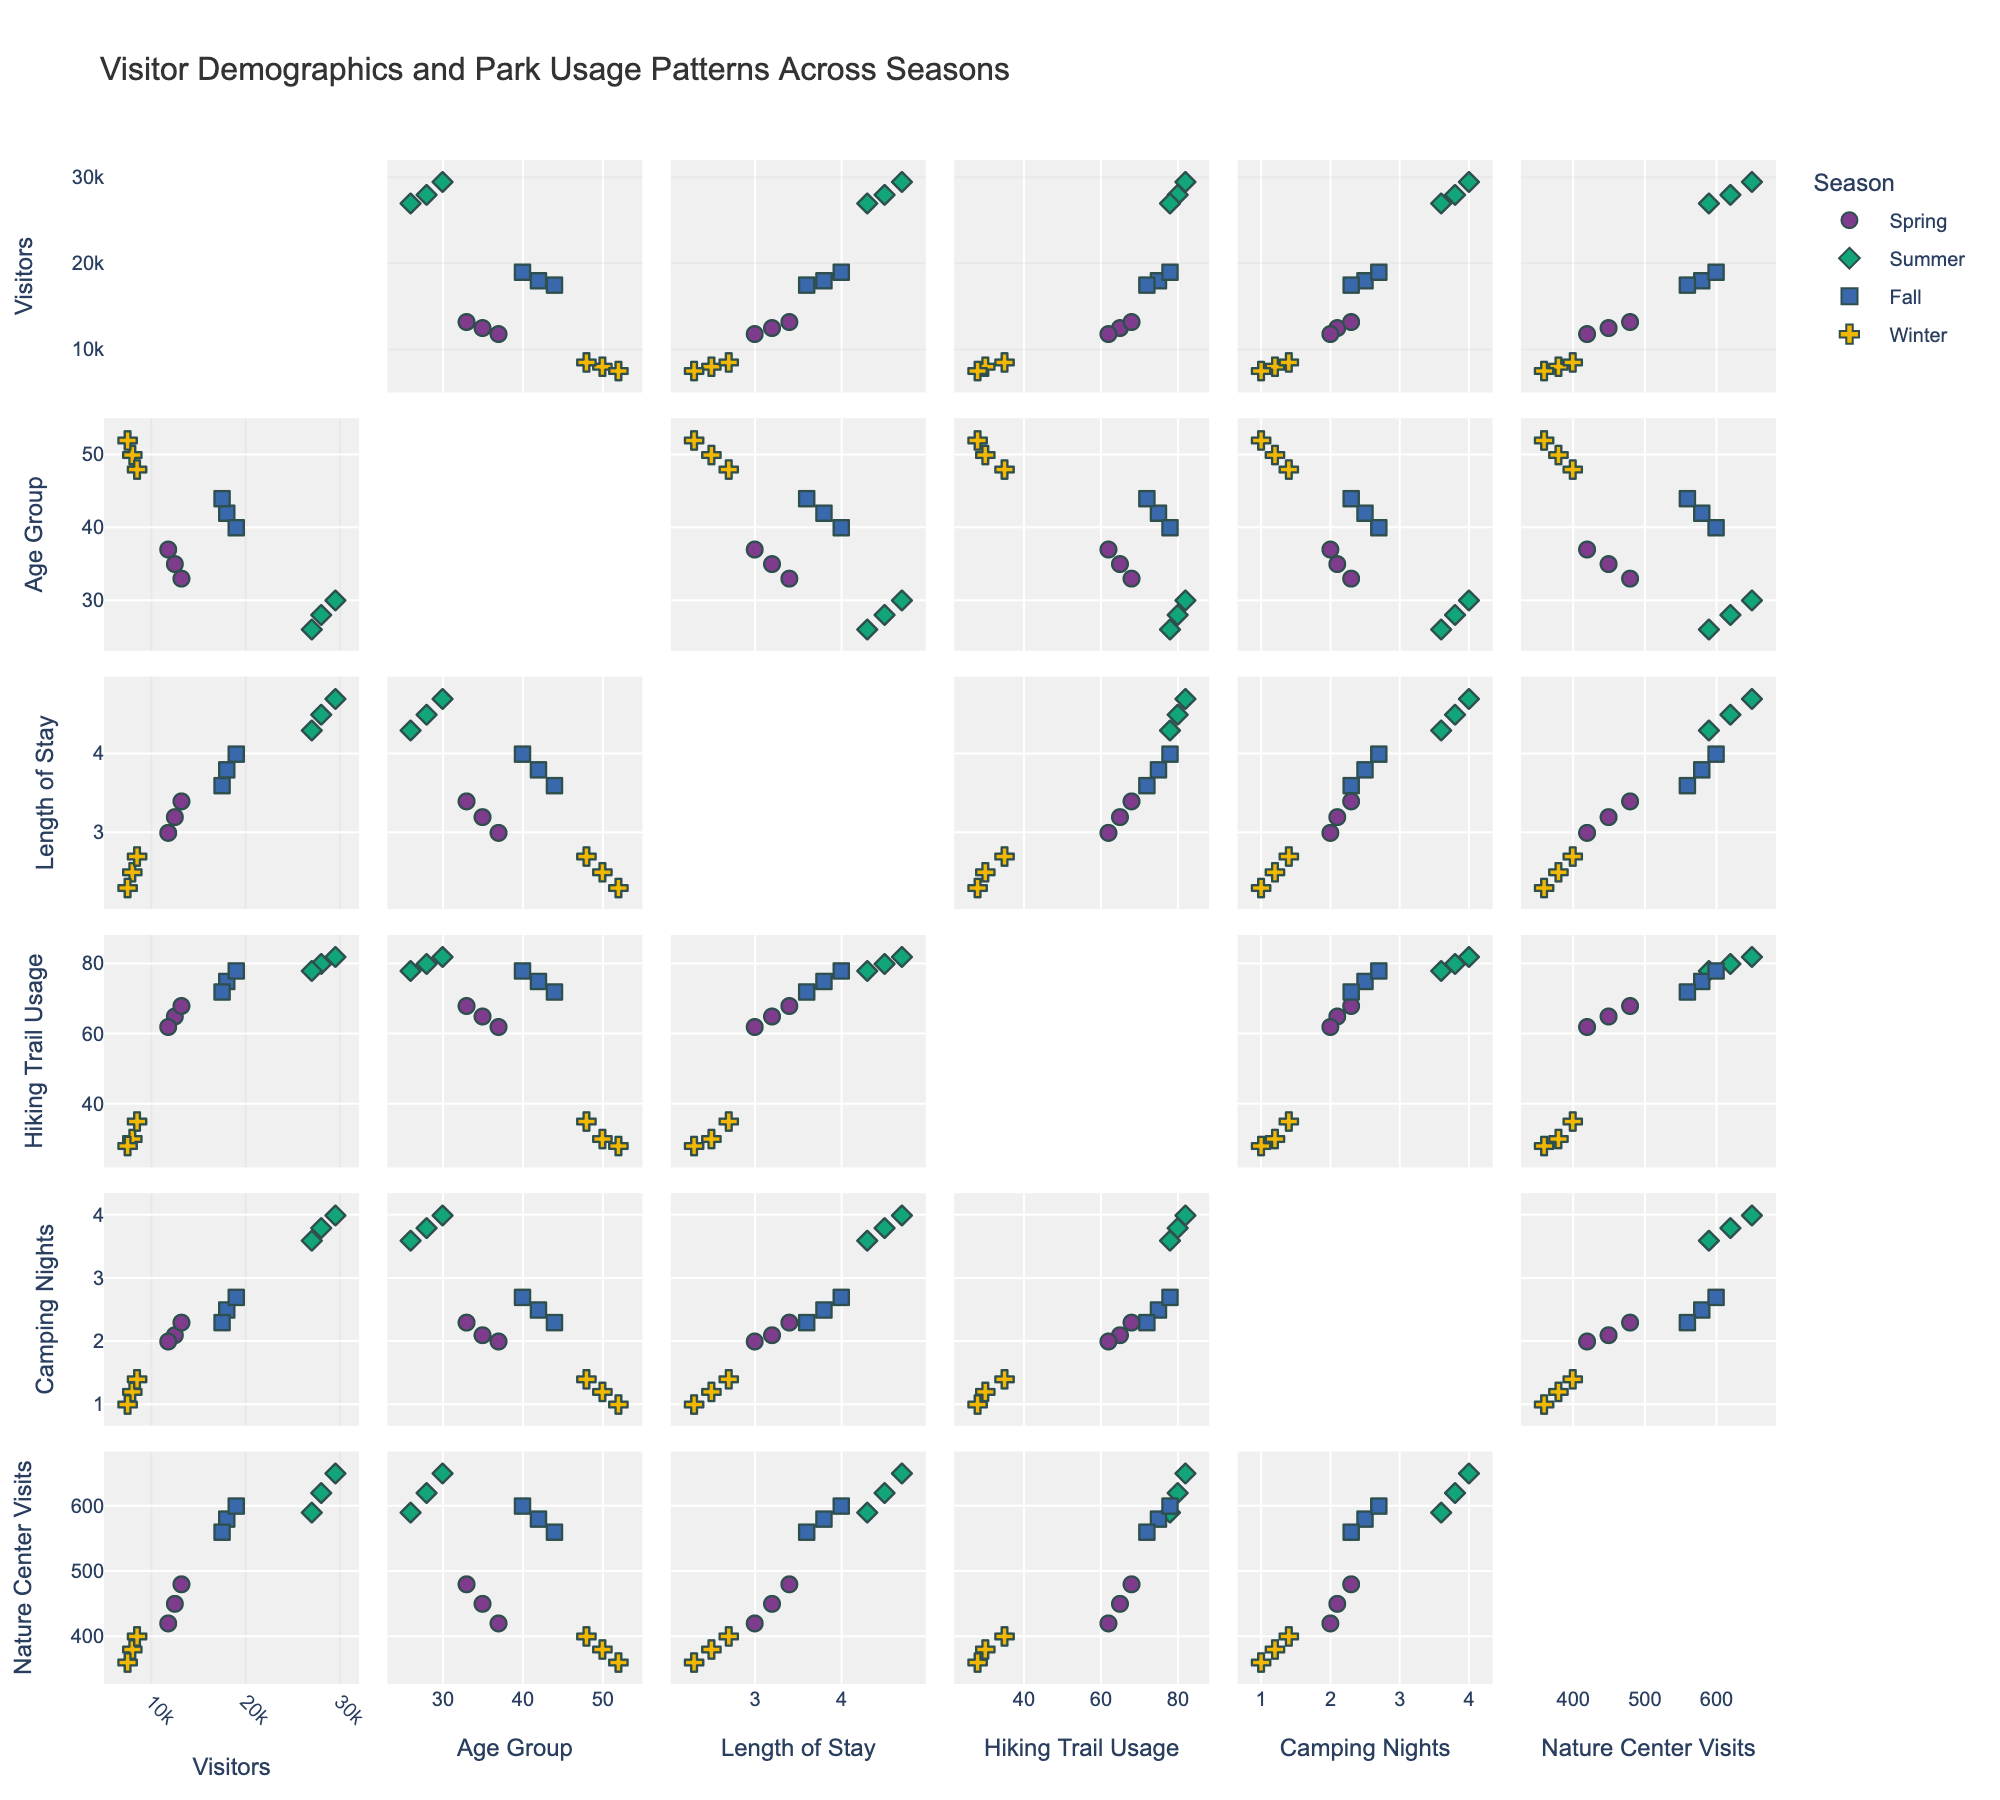What is the title of the scatterplot matrix? The title is usually displayed at the top of the scatterplot matrix. In this case, it is "Visitor Demographics and Park Usage Patterns Across Seasons".
Answer: Visitor Demographics and Park Usage Patterns Across Seasons Which season appears to have the highest number of visitors? From the scatterplot matrix, we see that the Summer season consistently has the highest visitors across the data points.
Answer: Summer How does the average length of stay compare between Spring and Winter? By observing the scatterplot matrix comparing Length of Stay and different Seasons, the length of stay in Winter is lower. We can calculate rough averages: Spring points are around 3.2, 3.4, and 3.0 which average to about 3.2; Winter points are 2.5, 2.7, and 2.3 which average to about 2.5.
Answer: Spring has a longer average stay Is there a correlation between Age Group and Nature Center Visits? By examining the scatterplot matrix of Age Group versus Nature Center Visits, if the points show a trend, such as increasing or decreasing, it indicates correlation. There is no obvious trend; thus, they are not strongly correlated.
Answer: No strong correlation Which season shows the most hiking trail usage? Checking the Hiking Trail Usage scatterplots, Summer has the highest usage values as indicated by the clustering of high data points near the upper range of the scale.
Answer: Summer Do visitors who stay longer tend to visit the Nature Center more? Looking at the scatterplots between Length of Stay and Nature Center Visits, we observe whether the points form a diagonal trend. There appears to be a positive correlation, indicating longer stays tend to correlate with more Nature Center visits.
Answer: Yes In which season do visitors spend the most nights camping? By focusing on the scatterplots of Camping Nights across different seasons, the highest values cluster in Summer, indicating it as the season with the most camping nights.
Answer: Summer How does the number of winter visitors compare to fall visitors? Observing the scatterplots of visitors for Winter and Fall, Winter consistently has fewer visitors than Fall. Fall points are significantly higher.
Answer: Fall has more visitors Are there any overlaps in the data points for Age Group and Visitors across different seasons? In the scatterplot matrix for Age Group versus Visitors, observe if different-colored points overlap or are distinct; there are some overlaps, especially between Spring, Fall, and Winter.
Answer: Yes, there are overlaps Which seasons have data points indicating the lowest Nightly camping stays and how do these compare across seasons? Cross-referencing the scatterplot for Camping Nights with each season, Winter consistently shows the lowest values, around 1.0 – 1.4. These values are lower than in the other seasons.
Answer: Winter has the lowest nightly camping stays 